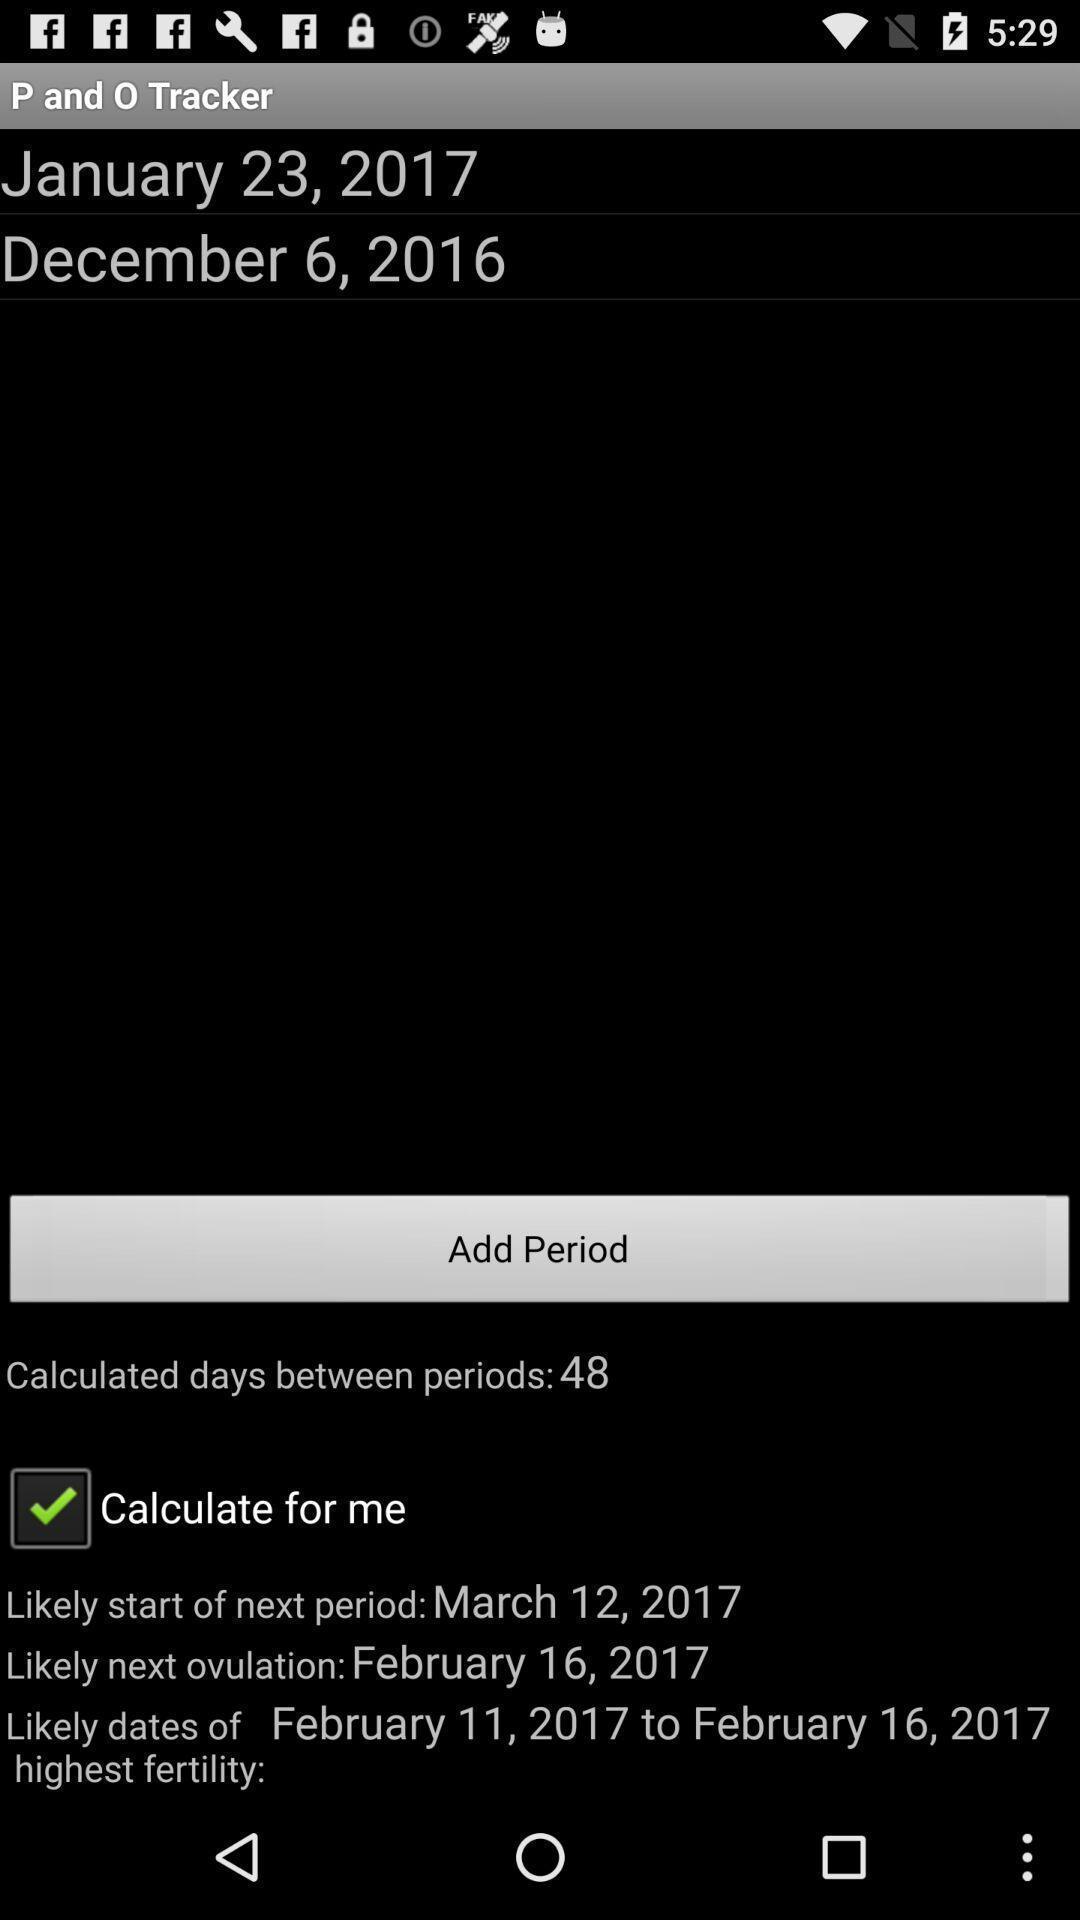Please provide a description for this image. Screen showing calculate for me. 